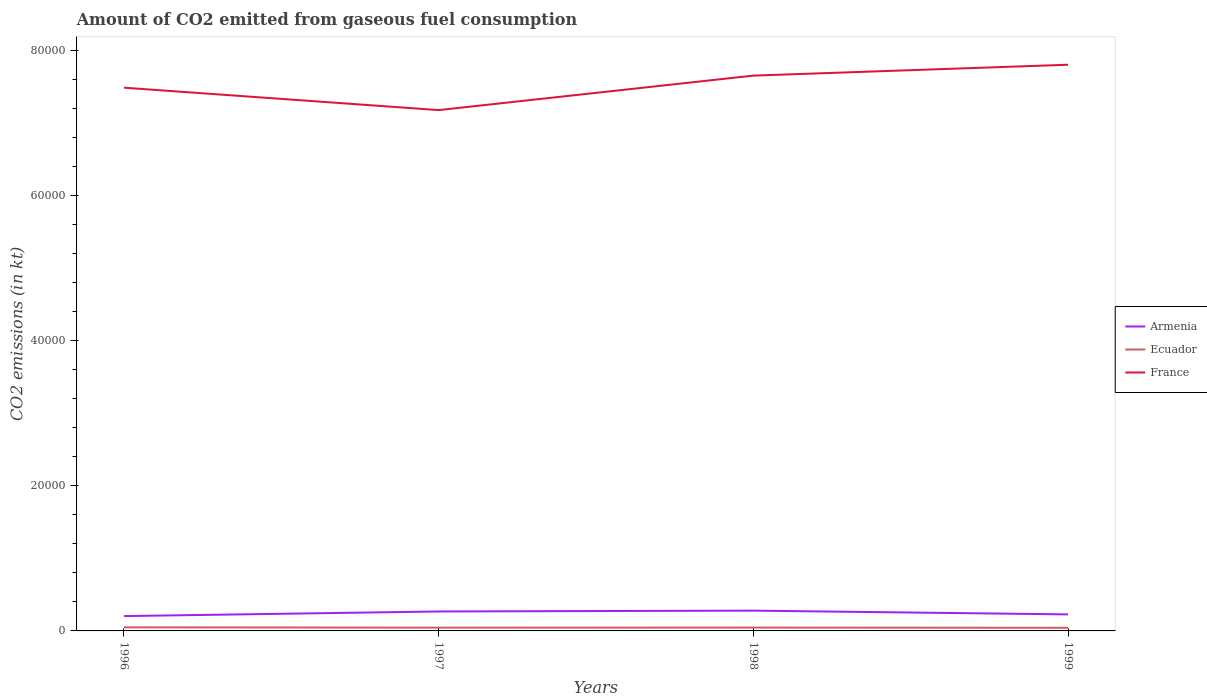How many different coloured lines are there?
Make the answer very short. 3. Is the number of lines equal to the number of legend labels?
Your answer should be very brief. Yes. Across all years, what is the maximum amount of CO2 emitted in France?
Offer a terse response. 7.18e+04. In which year was the amount of CO2 emitted in Ecuador maximum?
Offer a very short reply. 1999. What is the total amount of CO2 emitted in Armenia in the graph?
Keep it short and to the point. -234.69. What is the difference between the highest and the second highest amount of CO2 emitted in Armenia?
Give a very brief answer. 751.74. What is the difference between the highest and the lowest amount of CO2 emitted in France?
Provide a succinct answer. 2. Is the amount of CO2 emitted in Armenia strictly greater than the amount of CO2 emitted in Ecuador over the years?
Your answer should be compact. No. How many lines are there?
Your answer should be very brief. 3. How many years are there in the graph?
Offer a very short reply. 4. Does the graph contain any zero values?
Keep it short and to the point. No. What is the title of the graph?
Offer a terse response. Amount of CO2 emitted from gaseous fuel consumption. Does "Faeroe Islands" appear as one of the legend labels in the graph?
Keep it short and to the point. No. What is the label or title of the Y-axis?
Offer a very short reply. CO2 emissions (in kt). What is the CO2 emissions (in kt) of Armenia in 1996?
Offer a very short reply. 2042.52. What is the CO2 emissions (in kt) in Ecuador in 1996?
Ensure brevity in your answer.  495.05. What is the CO2 emissions (in kt) of France in 1996?
Provide a short and direct response. 7.49e+04. What is the CO2 emissions (in kt) of Armenia in 1997?
Make the answer very short. 2680.58. What is the CO2 emissions (in kt) of Ecuador in 1997?
Your response must be concise. 451.04. What is the CO2 emissions (in kt) of France in 1997?
Your answer should be very brief. 7.18e+04. What is the CO2 emissions (in kt) of Armenia in 1998?
Offer a very short reply. 2794.25. What is the CO2 emissions (in kt) of Ecuador in 1998?
Offer a very short reply. 462.04. What is the CO2 emissions (in kt) of France in 1998?
Provide a short and direct response. 7.65e+04. What is the CO2 emissions (in kt) of Armenia in 1999?
Your answer should be very brief. 2277.21. What is the CO2 emissions (in kt) in Ecuador in 1999?
Your answer should be very brief. 432.71. What is the CO2 emissions (in kt) of France in 1999?
Provide a succinct answer. 7.80e+04. Across all years, what is the maximum CO2 emissions (in kt) in Armenia?
Keep it short and to the point. 2794.25. Across all years, what is the maximum CO2 emissions (in kt) of Ecuador?
Give a very brief answer. 495.05. Across all years, what is the maximum CO2 emissions (in kt) in France?
Give a very brief answer. 7.80e+04. Across all years, what is the minimum CO2 emissions (in kt) of Armenia?
Your answer should be compact. 2042.52. Across all years, what is the minimum CO2 emissions (in kt) in Ecuador?
Provide a succinct answer. 432.71. Across all years, what is the minimum CO2 emissions (in kt) of France?
Ensure brevity in your answer.  7.18e+04. What is the total CO2 emissions (in kt) in Armenia in the graph?
Offer a very short reply. 9794.56. What is the total CO2 emissions (in kt) of Ecuador in the graph?
Give a very brief answer. 1840.83. What is the total CO2 emissions (in kt) in France in the graph?
Give a very brief answer. 3.01e+05. What is the difference between the CO2 emissions (in kt) in Armenia in 1996 and that in 1997?
Offer a very short reply. -638.06. What is the difference between the CO2 emissions (in kt) of Ecuador in 1996 and that in 1997?
Keep it short and to the point. 44. What is the difference between the CO2 emissions (in kt) in France in 1996 and that in 1997?
Provide a short and direct response. 3087.61. What is the difference between the CO2 emissions (in kt) in Armenia in 1996 and that in 1998?
Offer a very short reply. -751.74. What is the difference between the CO2 emissions (in kt) in Ecuador in 1996 and that in 1998?
Give a very brief answer. 33. What is the difference between the CO2 emissions (in kt) in France in 1996 and that in 1998?
Provide a succinct answer. -1664.82. What is the difference between the CO2 emissions (in kt) in Armenia in 1996 and that in 1999?
Provide a succinct answer. -234.69. What is the difference between the CO2 emissions (in kt) of Ecuador in 1996 and that in 1999?
Provide a succinct answer. 62.34. What is the difference between the CO2 emissions (in kt) of France in 1996 and that in 1999?
Give a very brief answer. -3164.62. What is the difference between the CO2 emissions (in kt) of Armenia in 1997 and that in 1998?
Give a very brief answer. -113.68. What is the difference between the CO2 emissions (in kt) of Ecuador in 1997 and that in 1998?
Make the answer very short. -11. What is the difference between the CO2 emissions (in kt) in France in 1997 and that in 1998?
Ensure brevity in your answer.  -4752.43. What is the difference between the CO2 emissions (in kt) in Armenia in 1997 and that in 1999?
Give a very brief answer. 403.37. What is the difference between the CO2 emissions (in kt) in Ecuador in 1997 and that in 1999?
Provide a short and direct response. 18.34. What is the difference between the CO2 emissions (in kt) of France in 1997 and that in 1999?
Make the answer very short. -6252.23. What is the difference between the CO2 emissions (in kt) of Armenia in 1998 and that in 1999?
Offer a terse response. 517.05. What is the difference between the CO2 emissions (in kt) in Ecuador in 1998 and that in 1999?
Your answer should be compact. 29.34. What is the difference between the CO2 emissions (in kt) of France in 1998 and that in 1999?
Make the answer very short. -1499.8. What is the difference between the CO2 emissions (in kt) in Armenia in 1996 and the CO2 emissions (in kt) in Ecuador in 1997?
Offer a very short reply. 1591.48. What is the difference between the CO2 emissions (in kt) in Armenia in 1996 and the CO2 emissions (in kt) in France in 1997?
Ensure brevity in your answer.  -6.97e+04. What is the difference between the CO2 emissions (in kt) in Ecuador in 1996 and the CO2 emissions (in kt) in France in 1997?
Give a very brief answer. -7.13e+04. What is the difference between the CO2 emissions (in kt) in Armenia in 1996 and the CO2 emissions (in kt) in Ecuador in 1998?
Make the answer very short. 1580.48. What is the difference between the CO2 emissions (in kt) in Armenia in 1996 and the CO2 emissions (in kt) in France in 1998?
Give a very brief answer. -7.45e+04. What is the difference between the CO2 emissions (in kt) in Ecuador in 1996 and the CO2 emissions (in kt) in France in 1998?
Ensure brevity in your answer.  -7.60e+04. What is the difference between the CO2 emissions (in kt) in Armenia in 1996 and the CO2 emissions (in kt) in Ecuador in 1999?
Keep it short and to the point. 1609.81. What is the difference between the CO2 emissions (in kt) of Armenia in 1996 and the CO2 emissions (in kt) of France in 1999?
Ensure brevity in your answer.  -7.60e+04. What is the difference between the CO2 emissions (in kt) of Ecuador in 1996 and the CO2 emissions (in kt) of France in 1999?
Offer a very short reply. -7.75e+04. What is the difference between the CO2 emissions (in kt) in Armenia in 1997 and the CO2 emissions (in kt) in Ecuador in 1998?
Keep it short and to the point. 2218.53. What is the difference between the CO2 emissions (in kt) of Armenia in 1997 and the CO2 emissions (in kt) of France in 1998?
Offer a very short reply. -7.38e+04. What is the difference between the CO2 emissions (in kt) of Ecuador in 1997 and the CO2 emissions (in kt) of France in 1998?
Provide a short and direct response. -7.61e+04. What is the difference between the CO2 emissions (in kt) of Armenia in 1997 and the CO2 emissions (in kt) of Ecuador in 1999?
Your response must be concise. 2247.87. What is the difference between the CO2 emissions (in kt) in Armenia in 1997 and the CO2 emissions (in kt) in France in 1999?
Your answer should be very brief. -7.53e+04. What is the difference between the CO2 emissions (in kt) of Ecuador in 1997 and the CO2 emissions (in kt) of France in 1999?
Your answer should be compact. -7.76e+04. What is the difference between the CO2 emissions (in kt) in Armenia in 1998 and the CO2 emissions (in kt) in Ecuador in 1999?
Offer a terse response. 2361.55. What is the difference between the CO2 emissions (in kt) of Armenia in 1998 and the CO2 emissions (in kt) of France in 1999?
Make the answer very short. -7.52e+04. What is the difference between the CO2 emissions (in kt) in Ecuador in 1998 and the CO2 emissions (in kt) in France in 1999?
Give a very brief answer. -7.76e+04. What is the average CO2 emissions (in kt) in Armenia per year?
Your answer should be very brief. 2448.64. What is the average CO2 emissions (in kt) of Ecuador per year?
Keep it short and to the point. 460.21. What is the average CO2 emissions (in kt) of France per year?
Your response must be concise. 7.53e+04. In the year 1996, what is the difference between the CO2 emissions (in kt) in Armenia and CO2 emissions (in kt) in Ecuador?
Your answer should be very brief. 1547.47. In the year 1996, what is the difference between the CO2 emissions (in kt) of Armenia and CO2 emissions (in kt) of France?
Make the answer very short. -7.28e+04. In the year 1996, what is the difference between the CO2 emissions (in kt) in Ecuador and CO2 emissions (in kt) in France?
Give a very brief answer. -7.44e+04. In the year 1997, what is the difference between the CO2 emissions (in kt) of Armenia and CO2 emissions (in kt) of Ecuador?
Your response must be concise. 2229.54. In the year 1997, what is the difference between the CO2 emissions (in kt) in Armenia and CO2 emissions (in kt) in France?
Your answer should be compact. -6.91e+04. In the year 1997, what is the difference between the CO2 emissions (in kt) in Ecuador and CO2 emissions (in kt) in France?
Give a very brief answer. -7.13e+04. In the year 1998, what is the difference between the CO2 emissions (in kt) of Armenia and CO2 emissions (in kt) of Ecuador?
Provide a succinct answer. 2332.21. In the year 1998, what is the difference between the CO2 emissions (in kt) of Armenia and CO2 emissions (in kt) of France?
Provide a short and direct response. -7.37e+04. In the year 1998, what is the difference between the CO2 emissions (in kt) in Ecuador and CO2 emissions (in kt) in France?
Ensure brevity in your answer.  -7.61e+04. In the year 1999, what is the difference between the CO2 emissions (in kt) in Armenia and CO2 emissions (in kt) in Ecuador?
Ensure brevity in your answer.  1844.5. In the year 1999, what is the difference between the CO2 emissions (in kt) in Armenia and CO2 emissions (in kt) in France?
Provide a short and direct response. -7.57e+04. In the year 1999, what is the difference between the CO2 emissions (in kt) in Ecuador and CO2 emissions (in kt) in France?
Keep it short and to the point. -7.76e+04. What is the ratio of the CO2 emissions (in kt) in Armenia in 1996 to that in 1997?
Provide a succinct answer. 0.76. What is the ratio of the CO2 emissions (in kt) in Ecuador in 1996 to that in 1997?
Provide a short and direct response. 1.1. What is the ratio of the CO2 emissions (in kt) in France in 1996 to that in 1997?
Offer a very short reply. 1.04. What is the ratio of the CO2 emissions (in kt) of Armenia in 1996 to that in 1998?
Ensure brevity in your answer.  0.73. What is the ratio of the CO2 emissions (in kt) of Ecuador in 1996 to that in 1998?
Keep it short and to the point. 1.07. What is the ratio of the CO2 emissions (in kt) of France in 1996 to that in 1998?
Offer a terse response. 0.98. What is the ratio of the CO2 emissions (in kt) in Armenia in 1996 to that in 1999?
Ensure brevity in your answer.  0.9. What is the ratio of the CO2 emissions (in kt) of Ecuador in 1996 to that in 1999?
Provide a succinct answer. 1.14. What is the ratio of the CO2 emissions (in kt) of France in 1996 to that in 1999?
Provide a short and direct response. 0.96. What is the ratio of the CO2 emissions (in kt) in Armenia in 1997 to that in 1998?
Your response must be concise. 0.96. What is the ratio of the CO2 emissions (in kt) in Ecuador in 1997 to that in 1998?
Your response must be concise. 0.98. What is the ratio of the CO2 emissions (in kt) of France in 1997 to that in 1998?
Your answer should be very brief. 0.94. What is the ratio of the CO2 emissions (in kt) in Armenia in 1997 to that in 1999?
Make the answer very short. 1.18. What is the ratio of the CO2 emissions (in kt) in Ecuador in 1997 to that in 1999?
Your response must be concise. 1.04. What is the ratio of the CO2 emissions (in kt) in France in 1997 to that in 1999?
Your answer should be very brief. 0.92. What is the ratio of the CO2 emissions (in kt) in Armenia in 1998 to that in 1999?
Offer a very short reply. 1.23. What is the ratio of the CO2 emissions (in kt) in Ecuador in 1998 to that in 1999?
Give a very brief answer. 1.07. What is the ratio of the CO2 emissions (in kt) of France in 1998 to that in 1999?
Give a very brief answer. 0.98. What is the difference between the highest and the second highest CO2 emissions (in kt) in Armenia?
Your answer should be very brief. 113.68. What is the difference between the highest and the second highest CO2 emissions (in kt) of Ecuador?
Provide a short and direct response. 33. What is the difference between the highest and the second highest CO2 emissions (in kt) of France?
Provide a succinct answer. 1499.8. What is the difference between the highest and the lowest CO2 emissions (in kt) in Armenia?
Provide a succinct answer. 751.74. What is the difference between the highest and the lowest CO2 emissions (in kt) in Ecuador?
Your answer should be compact. 62.34. What is the difference between the highest and the lowest CO2 emissions (in kt) in France?
Keep it short and to the point. 6252.23. 